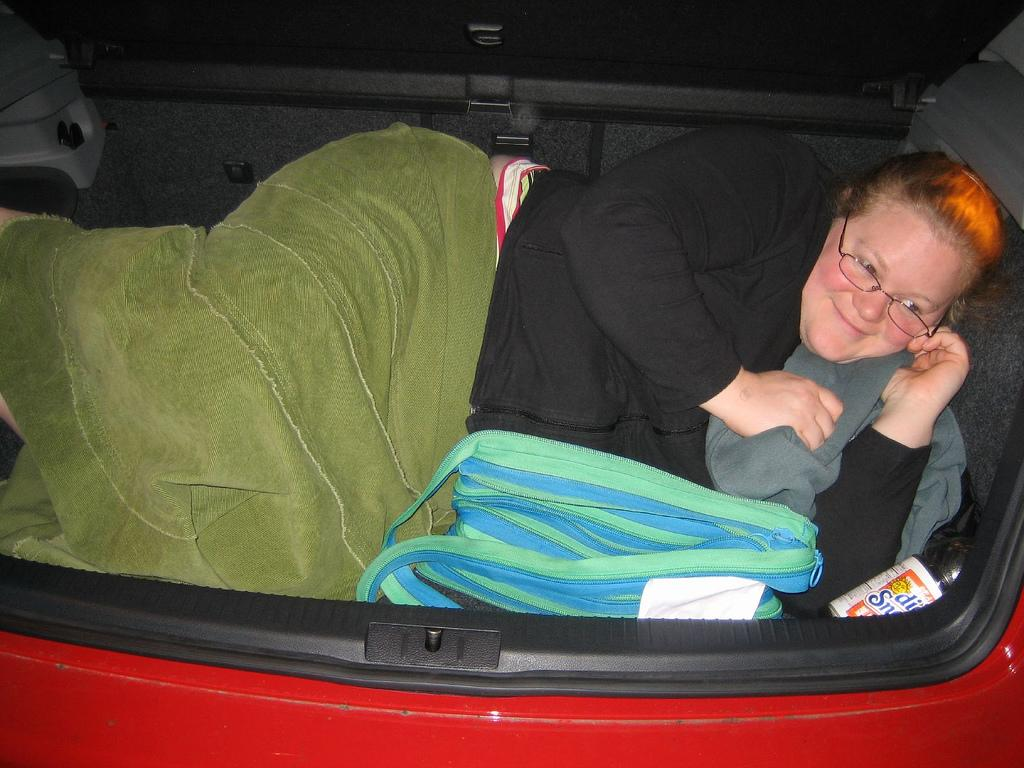What is the lady doing in the car? The lady is lying in the car. What color is the car? The car is red in color. What can be seen inside the car? There are objects placed in the car. What school does the lady attend in the image? There is no indication of a school or any educational setting in the image. 